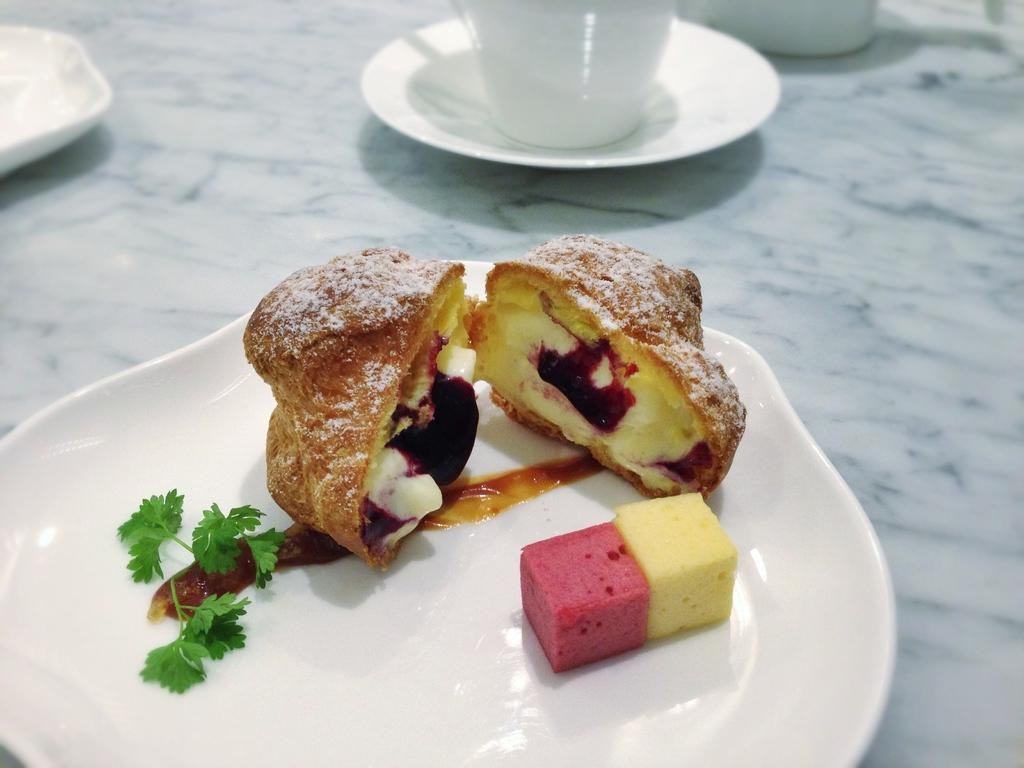What is on the plate that is visible in the image? The plate contains food items. What other items can be seen in the image besides the plate? There is a cup and saucer, as well as two bowls, in the image. What type of surface are the items placed on? The items are placed on a marble surface. What type of trousers is the plate wearing in the image? The plate is not a living being and therefore cannot wear trousers. --- Facts: 1. There is a person sitting on a chair in the image. 2. The person is holding a book. 3. The book has a blue cover. 4. There is a table next to the chair. 5. The table has a lamp on it. Absurd Topics: parrot, bicycle, ocean Conversation: What is the person in the image doing? The person is sitting on a chair in the image. What object is the person holding? The person is holding a book. What is the color of the book's cover? The book has a blue cover. What is located next to the chair? There is a table next to the chair. What item is on the table? The table has a lamp on it. Reasoning: Let's think step by step in order to produce the conversation. We start by identifying the main subject in the image, which is the person sitting on a chair. Then, we expand the conversation to include other items that are also visible, such as the book, the table, and the lamp. We also mention the color of the book's cover, which is blue. Each question is designed to elicit a specific detail about the image that is known from the provided facts. Absurd Question/Answer: Can you see the ocean in the background of the image? There is no ocean visible in the image. 